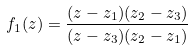Convert formula to latex. <formula><loc_0><loc_0><loc_500><loc_500>f _ { 1 } ( z ) = { \frac { ( z - z _ { 1 } ) ( z _ { 2 } - z _ { 3 } ) } { ( z - z _ { 3 } ) ( z _ { 2 } - z _ { 1 } ) } }</formula> 